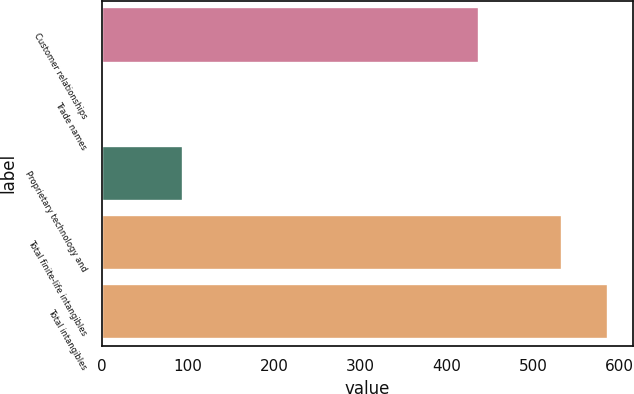Convert chart. <chart><loc_0><loc_0><loc_500><loc_500><bar_chart><fcel>Customer relationships<fcel>Trade names<fcel>Proprietary technology and<fcel>Total finite-life intangibles<fcel>Total intangibles<nl><fcel>437.5<fcel>1.4<fcel>94.2<fcel>533.1<fcel>586.27<nl></chart> 